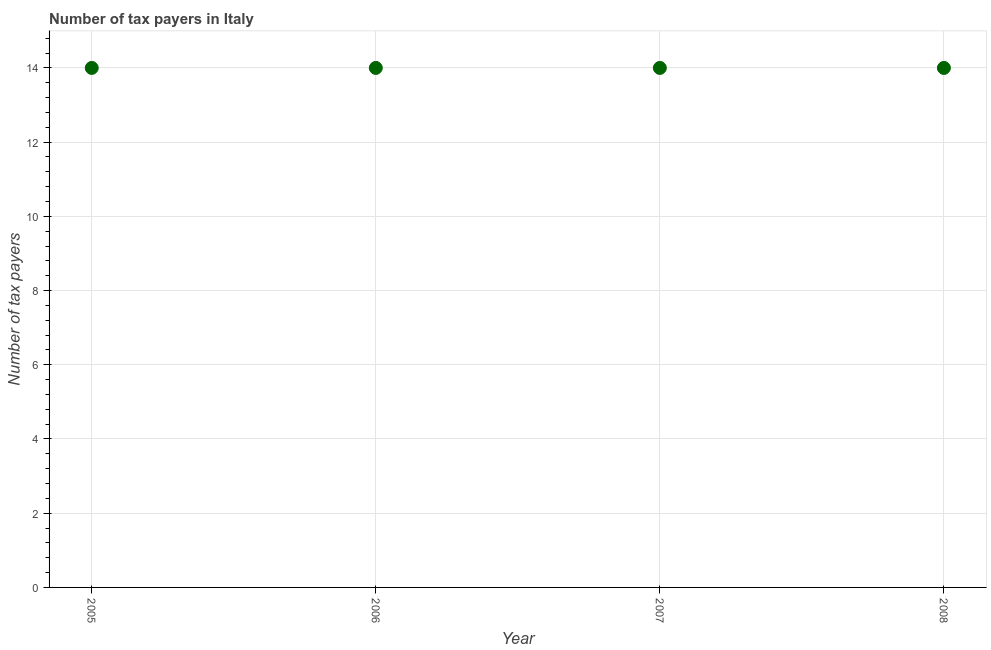What is the number of tax payers in 2007?
Give a very brief answer. 14. Across all years, what is the maximum number of tax payers?
Your answer should be compact. 14. Across all years, what is the minimum number of tax payers?
Provide a succinct answer. 14. In which year was the number of tax payers maximum?
Your answer should be compact. 2005. In which year was the number of tax payers minimum?
Keep it short and to the point. 2005. What is the sum of the number of tax payers?
Make the answer very short. 56. What is the median number of tax payers?
Make the answer very short. 14. In how many years, is the number of tax payers greater than 2 ?
Your answer should be very brief. 4. Do a majority of the years between 2007 and 2008 (inclusive) have number of tax payers greater than 6.8 ?
Your response must be concise. Yes. Is the number of tax payers in 2005 less than that in 2008?
Your answer should be very brief. No. What is the difference between the highest and the second highest number of tax payers?
Ensure brevity in your answer.  0. What is the difference between the highest and the lowest number of tax payers?
Provide a succinct answer. 0. In how many years, is the number of tax payers greater than the average number of tax payers taken over all years?
Give a very brief answer. 0. How many dotlines are there?
Keep it short and to the point. 1. What is the difference between two consecutive major ticks on the Y-axis?
Your answer should be compact. 2. What is the title of the graph?
Offer a very short reply. Number of tax payers in Italy. What is the label or title of the Y-axis?
Provide a short and direct response. Number of tax payers. What is the Number of tax payers in 2005?
Provide a succinct answer. 14. What is the difference between the Number of tax payers in 2005 and 2006?
Provide a succinct answer. 0. What is the difference between the Number of tax payers in 2005 and 2008?
Make the answer very short. 0. What is the difference between the Number of tax payers in 2006 and 2007?
Keep it short and to the point. 0. What is the difference between the Number of tax payers in 2006 and 2008?
Your response must be concise. 0. What is the ratio of the Number of tax payers in 2005 to that in 2006?
Provide a short and direct response. 1. What is the ratio of the Number of tax payers in 2007 to that in 2008?
Give a very brief answer. 1. 